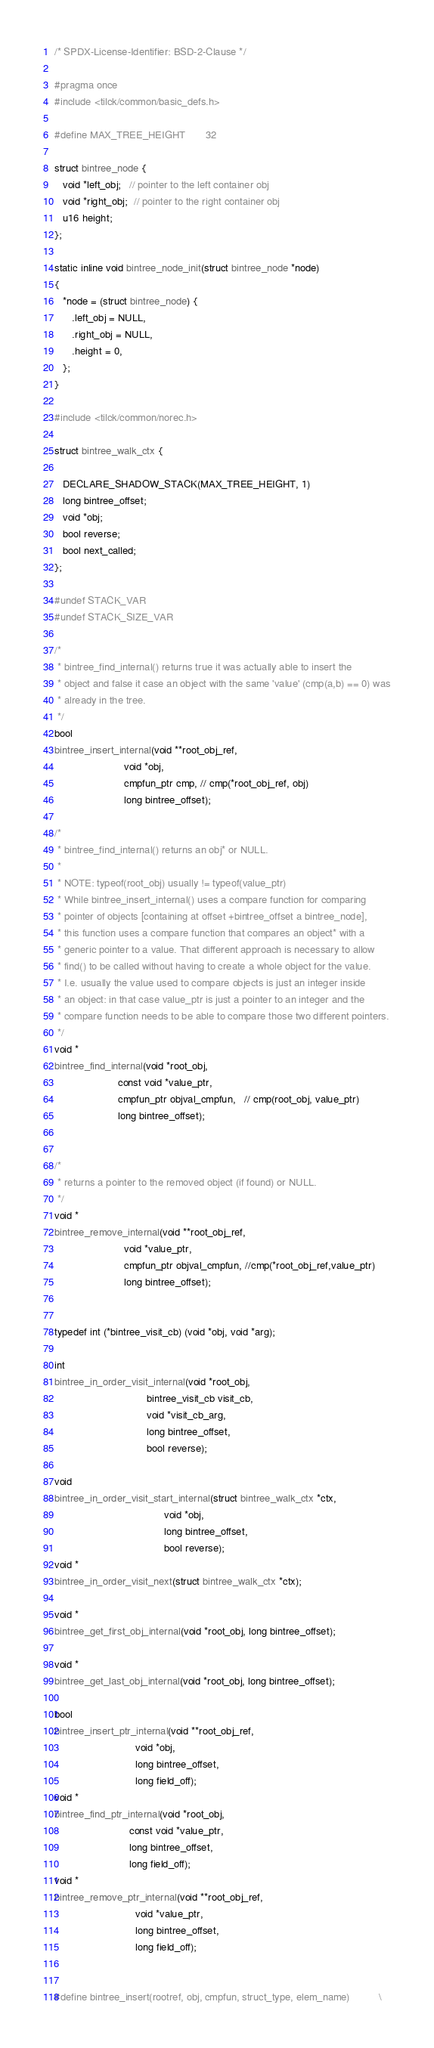Convert code to text. <code><loc_0><loc_0><loc_500><loc_500><_C_>/* SPDX-License-Identifier: BSD-2-Clause */

#pragma once
#include <tilck/common/basic_defs.h>

#define MAX_TREE_HEIGHT       32

struct bintree_node {
   void *left_obj;   // pointer to the left container obj
   void *right_obj;  // pointer to the right container obj
   u16 height;
};

static inline void bintree_node_init(struct bintree_node *node)
{
   *node = (struct bintree_node) {
      .left_obj = NULL,
      .right_obj = NULL,
      .height = 0,
   };
}

#include <tilck/common/norec.h>

struct bintree_walk_ctx {

   DECLARE_SHADOW_STACK(MAX_TREE_HEIGHT, 1)
   long bintree_offset;
   void *obj;
   bool reverse;
   bool next_called;
};

#undef STACK_VAR
#undef STACK_SIZE_VAR

/*
 * bintree_find_internal() returns true it was actually able to insert the
 * object and false it case an object with the same 'value' (cmp(a,b) == 0) was
 * already in the tree.
 */
bool
bintree_insert_internal(void **root_obj_ref,
                        void *obj,
                        cmpfun_ptr cmp, // cmp(*root_obj_ref, obj)
                        long bintree_offset);

/*
 * bintree_find_internal() returns an obj* or NULL.
 *
 * NOTE: typeof(root_obj) usually != typeof(value_ptr)
 * While bintree_insert_internal() uses a compare function for comparing
 * pointer of objects [containing at offset +bintree_offset a bintree_node],
 * this function uses a compare function that compares an object* with a
 * generic pointer to a value. That different approach is necessary to allow
 * find() to be called without having to create a whole object for the value.
 * I.e. usually the value used to compare objects is just an integer inside
 * an object: in that case value_ptr is just a pointer to an integer and the
 * compare function needs to be able to compare those two different pointers.
 */
void *
bintree_find_internal(void *root_obj,
                      const void *value_ptr,
                      cmpfun_ptr objval_cmpfun,   // cmp(root_obj, value_ptr)
                      long bintree_offset);


/*
 * returns a pointer to the removed object (if found) or NULL.
 */
void *
bintree_remove_internal(void **root_obj_ref,
                        void *value_ptr,
                        cmpfun_ptr objval_cmpfun, //cmp(*root_obj_ref,value_ptr)
                        long bintree_offset);


typedef int (*bintree_visit_cb) (void *obj, void *arg);

int
bintree_in_order_visit_internal(void *root_obj,
                                bintree_visit_cb visit_cb,
                                void *visit_cb_arg,
                                long bintree_offset,
                                bool reverse);

void
bintree_in_order_visit_start_internal(struct bintree_walk_ctx *ctx,
                                      void *obj,
                                      long bintree_offset,
                                      bool reverse);
void *
bintree_in_order_visit_next(struct bintree_walk_ctx *ctx);

void *
bintree_get_first_obj_internal(void *root_obj, long bintree_offset);

void *
bintree_get_last_obj_internal(void *root_obj, long bintree_offset);

bool
bintree_insert_ptr_internal(void **root_obj_ref,
                            void *obj,
                            long bintree_offset,
                            long field_off);
void *
bintree_find_ptr_internal(void *root_obj,
                          const void *value_ptr,
                          long bintree_offset,
                          long field_off);
void *
bintree_remove_ptr_internal(void **root_obj_ref,
                            void *value_ptr,
                            long bintree_offset,
                            long field_off);


#define bintree_insert(rootref, obj, cmpfun, struct_type, elem_name)          \</code> 